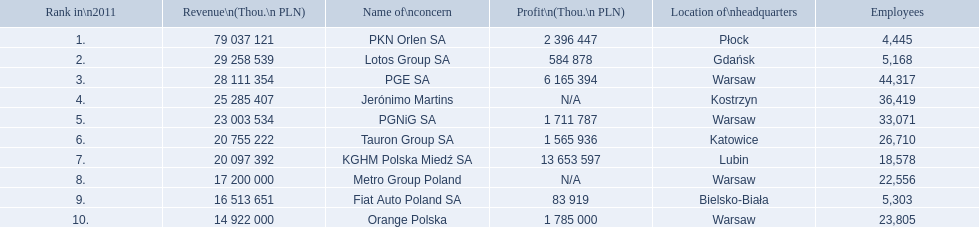What company has 28 111 354 thou.in revenue? PGE SA. What revenue does lotus group sa have? 29 258 539. Who has the next highest revenue than lotus group sa? PKN Orlen SA. 